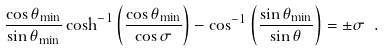<formula> <loc_0><loc_0><loc_500><loc_500>\frac { \cos \theta _ { \min } } { \sin \theta _ { \min } } \cosh ^ { - 1 } \left ( \frac { \cos \theta _ { \min } } { \cos \sigma } \right ) - \cos ^ { - 1 } \left ( \frac { \sin \theta _ { \min } } { \sin \theta } \right ) = \pm \sigma \ .</formula> 